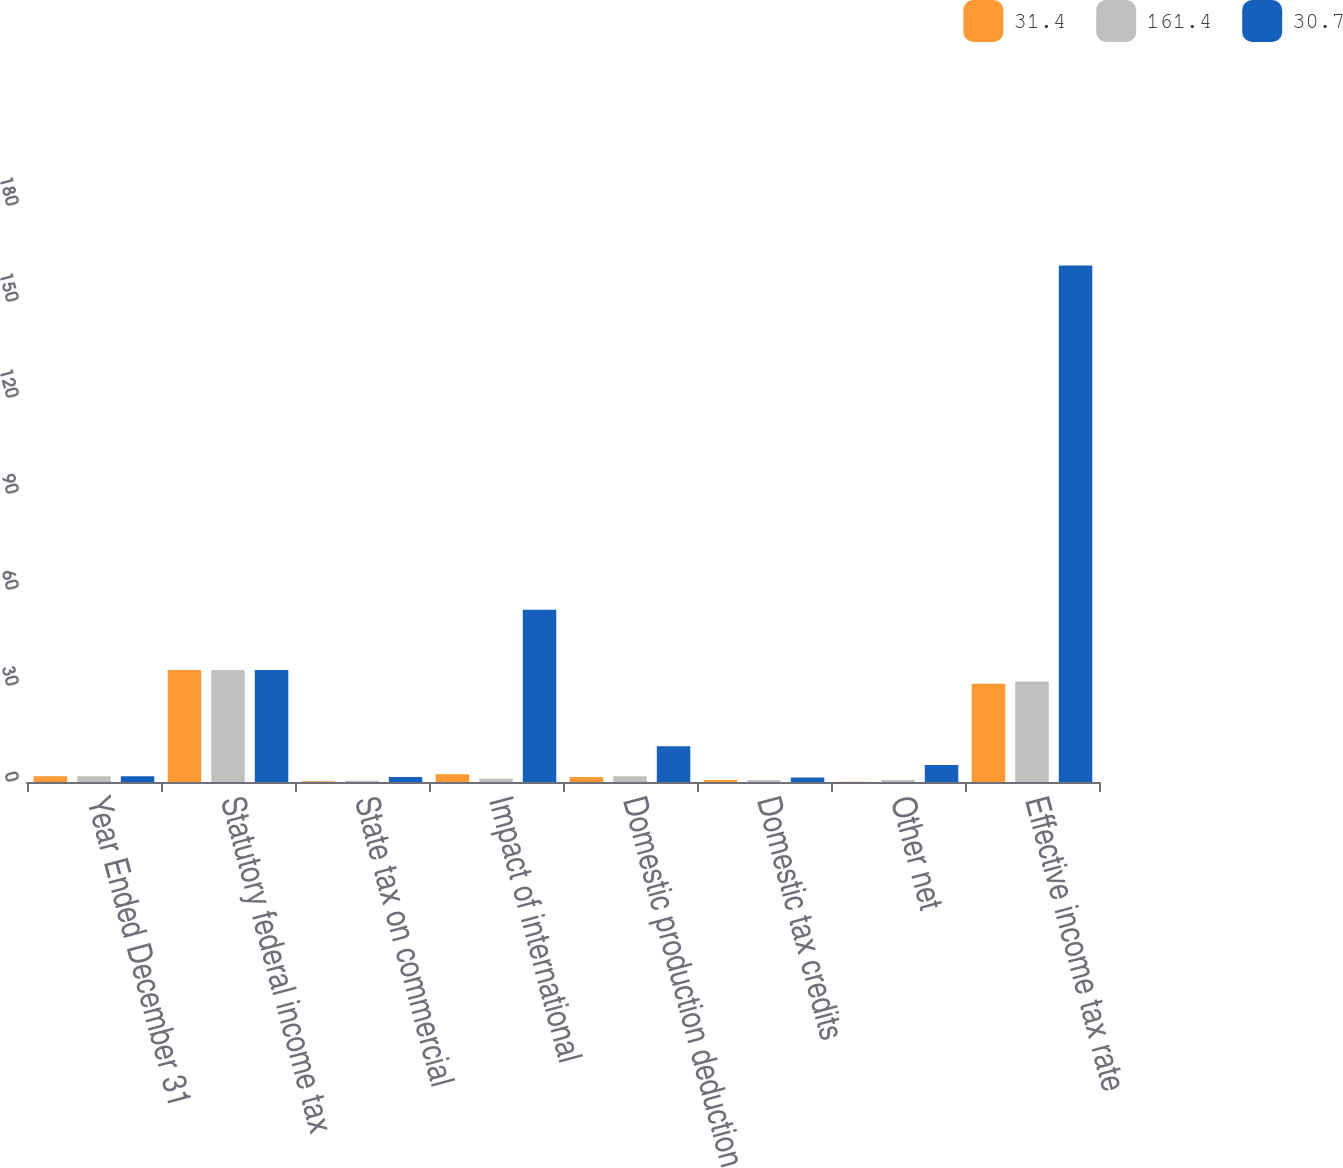Convert chart to OTSL. <chart><loc_0><loc_0><loc_500><loc_500><stacked_bar_chart><ecel><fcel>Year Ended December 31<fcel>Statutory federal income tax<fcel>State tax on commercial<fcel>Impact of international<fcel>Domestic production deduction<fcel>Domestic tax credits<fcel>Other net<fcel>Effective income tax rate<nl><fcel>31.4<fcel>1.8<fcel>35<fcel>0.2<fcel>2.4<fcel>1.6<fcel>0.6<fcel>0.1<fcel>30.7<nl><fcel>161.4<fcel>1.8<fcel>35<fcel>0.4<fcel>1<fcel>1.8<fcel>0.6<fcel>0.6<fcel>31.4<nl><fcel>30.7<fcel>1.8<fcel>35<fcel>1.6<fcel>53.8<fcel>11.2<fcel>1.4<fcel>5.3<fcel>161.4<nl></chart> 